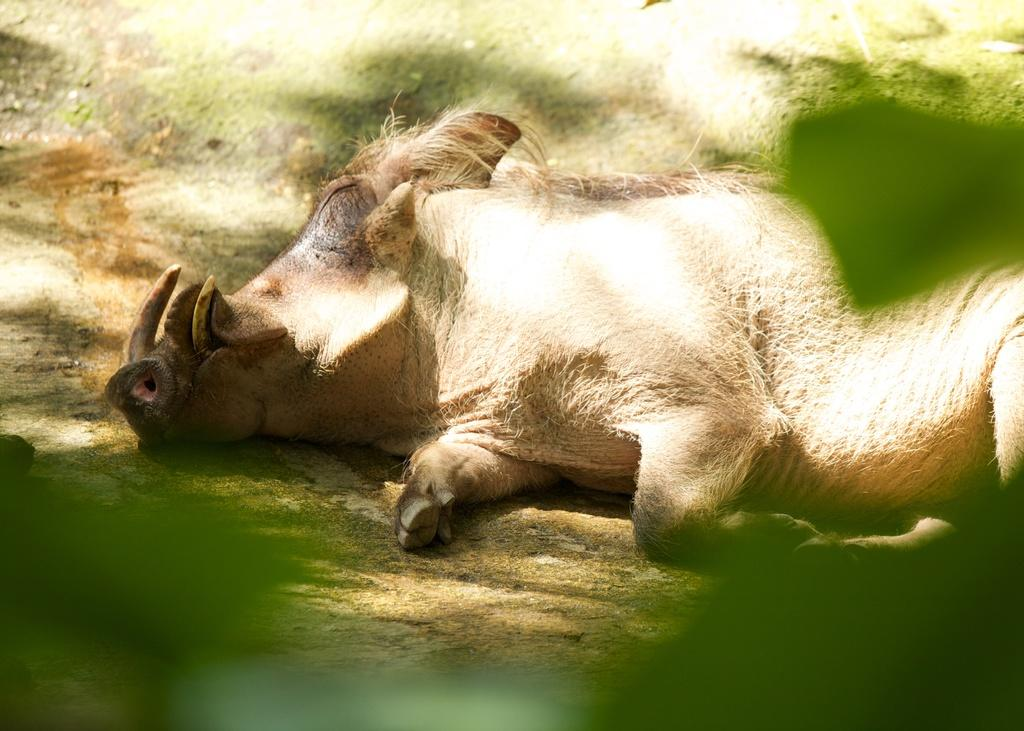What can be seen in the front of the image? There are green color blurry things in the front of the image. What is visible in the background of the image? There is a pig visible in the background of the image. What type of scent can be smelled coming from the green color blurry things in the image? There is no indication of a scent in the image, as it only contains visual information. How many teeth does the pig have in the image? The image does not show the pig's teeth, so it is not possible to determine how many teeth the pig has. 